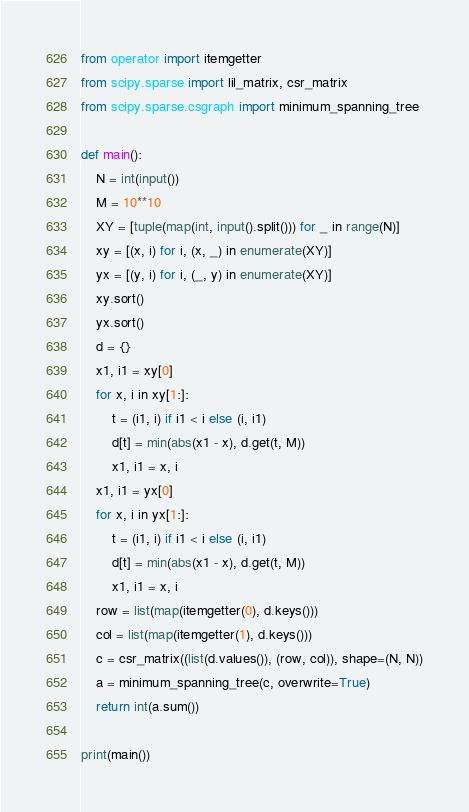Convert code to text. <code><loc_0><loc_0><loc_500><loc_500><_Python_>from operator import itemgetter
from scipy.sparse import lil_matrix, csr_matrix
from scipy.sparse.csgraph import minimum_spanning_tree

def main():
    N = int(input())
    M = 10**10
    XY = [tuple(map(int, input().split())) for _ in range(N)]
    xy = [(x, i) for i, (x, _) in enumerate(XY)]
    yx = [(y, i) for i, (_, y) in enumerate(XY)]
    xy.sort()
    yx.sort()
    d = {}
    x1, i1 = xy[0]
    for x, i in xy[1:]:
        t = (i1, i) if i1 < i else (i, i1)
        d[t] = min(abs(x1 - x), d.get(t, M))
        x1, i1 = x, i
    x1, i1 = yx[0]
    for x, i in yx[1:]:
        t = (i1, i) if i1 < i else (i, i1)
        d[t] = min(abs(x1 - x), d.get(t, M))
        x1, i1 = x, i
    row = list(map(itemgetter(0), d.keys()))
    col = list(map(itemgetter(1), d.keys()))
    c = csr_matrix((list(d.values()), (row, col)), shape=(N, N))
    a = minimum_spanning_tree(c, overwrite=True)
    return int(a.sum())

print(main())
</code> 